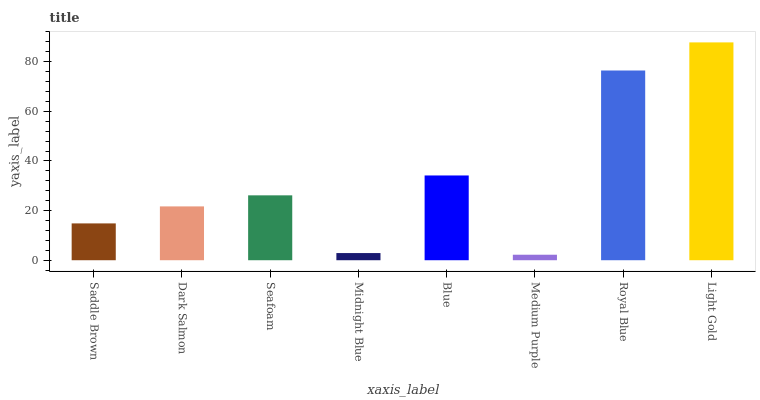Is Medium Purple the minimum?
Answer yes or no. Yes. Is Light Gold the maximum?
Answer yes or no. Yes. Is Dark Salmon the minimum?
Answer yes or no. No. Is Dark Salmon the maximum?
Answer yes or no. No. Is Dark Salmon greater than Saddle Brown?
Answer yes or no. Yes. Is Saddle Brown less than Dark Salmon?
Answer yes or no. Yes. Is Saddle Brown greater than Dark Salmon?
Answer yes or no. No. Is Dark Salmon less than Saddle Brown?
Answer yes or no. No. Is Seafoam the high median?
Answer yes or no. Yes. Is Dark Salmon the low median?
Answer yes or no. Yes. Is Medium Purple the high median?
Answer yes or no. No. Is Blue the low median?
Answer yes or no. No. 